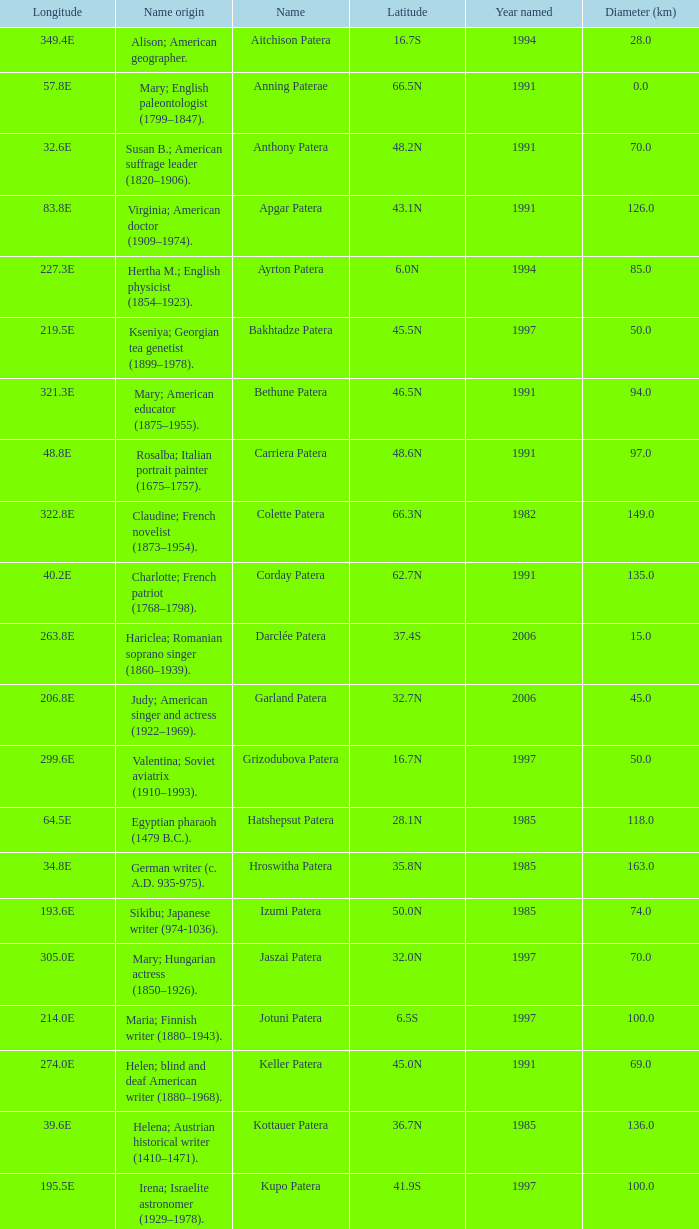What is the origin of the name of Keller Patera?  Helen; blind and deaf American writer (1880–1968). 